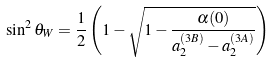Convert formula to latex. <formula><loc_0><loc_0><loc_500><loc_500>\sin ^ { 2 } \theta _ { W } = \frac { 1 } { 2 } \left ( 1 - \sqrt { 1 - \frac { \alpha ( 0 ) } { a _ { 2 } ^ { ( 3 B ) } - a _ { 2 } ^ { ( 3 A ) } } } \right )</formula> 